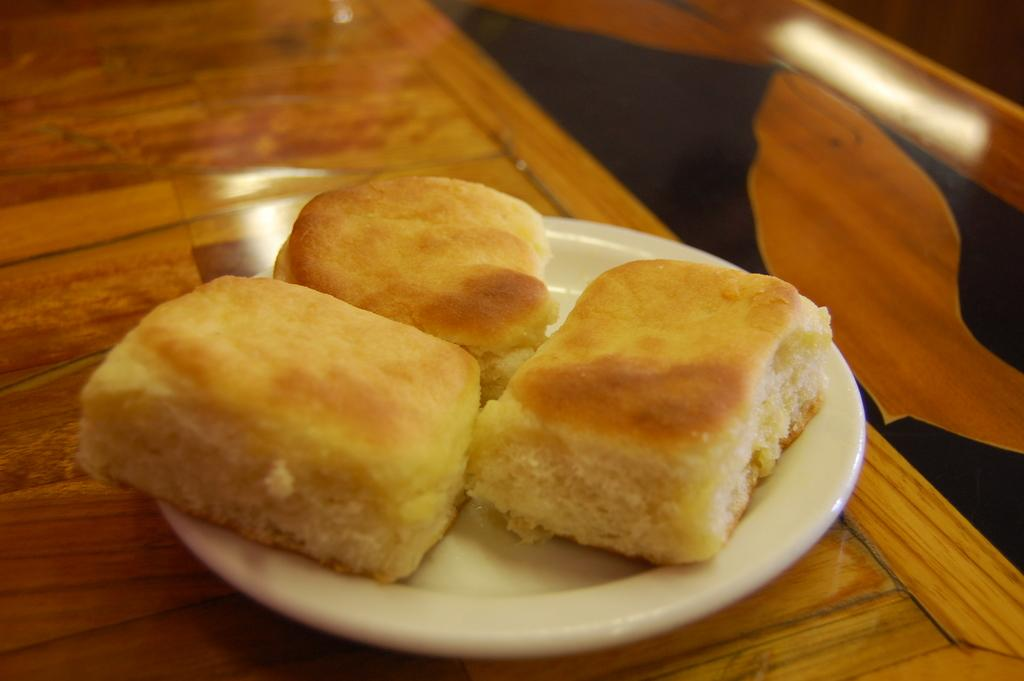What is on the plate that is visible in the image? There is a food item on a plate in the image. Where is the plate located in the image? The plate is placed on a table in the image. How many cows are visible on the page in the image? There are no cows or pages present in the image; it only features a food item on a plate placed on a table. 